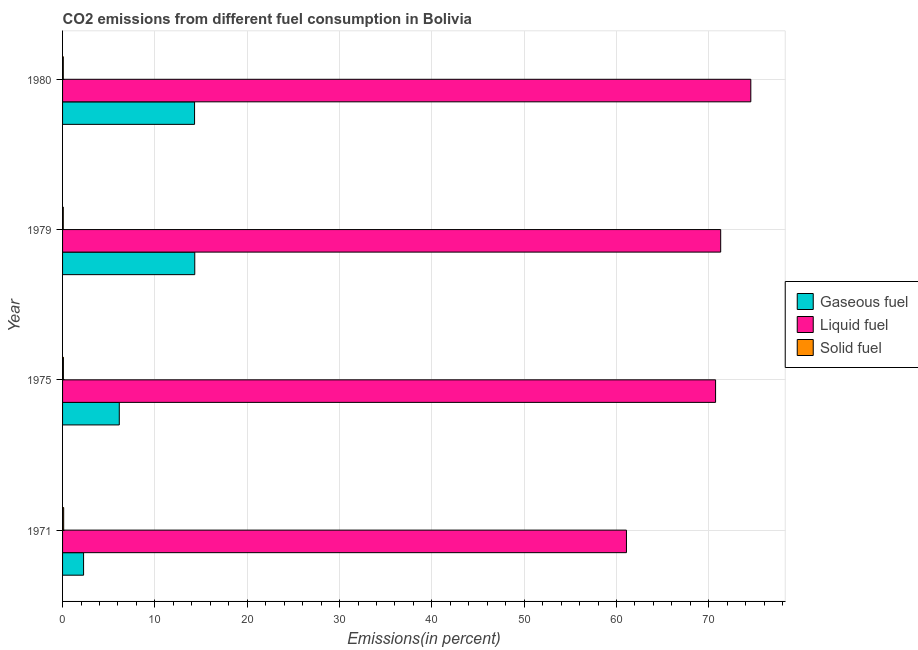How many different coloured bars are there?
Provide a succinct answer. 3. How many groups of bars are there?
Give a very brief answer. 4. In how many cases, is the number of bars for a given year not equal to the number of legend labels?
Offer a very short reply. 0. What is the percentage of gaseous fuel emission in 1971?
Your response must be concise. 2.28. Across all years, what is the maximum percentage of liquid fuel emission?
Keep it short and to the point. 74.55. Across all years, what is the minimum percentage of solid fuel emission?
Your answer should be very brief. 0.08. In which year was the percentage of gaseous fuel emission maximum?
Your response must be concise. 1979. In which year was the percentage of gaseous fuel emission minimum?
Your answer should be very brief. 1971. What is the total percentage of solid fuel emission in the graph?
Ensure brevity in your answer.  0.37. What is the difference between the percentage of solid fuel emission in 1971 and that in 1980?
Your response must be concise. 0.04. What is the difference between the percentage of liquid fuel emission in 1979 and the percentage of gaseous fuel emission in 1971?
Your answer should be very brief. 69.01. What is the average percentage of solid fuel emission per year?
Keep it short and to the point. 0.09. In the year 1975, what is the difference between the percentage of solid fuel emission and percentage of gaseous fuel emission?
Offer a terse response. -6.05. Is the difference between the percentage of solid fuel emission in 1975 and 1980 greater than the difference between the percentage of gaseous fuel emission in 1975 and 1980?
Ensure brevity in your answer.  Yes. What is the difference between the highest and the second highest percentage of gaseous fuel emission?
Your response must be concise. 0.02. What is the difference between the highest and the lowest percentage of liquid fuel emission?
Ensure brevity in your answer.  13.47. In how many years, is the percentage of solid fuel emission greater than the average percentage of solid fuel emission taken over all years?
Offer a very short reply. 1. Is the sum of the percentage of solid fuel emission in 1979 and 1980 greater than the maximum percentage of gaseous fuel emission across all years?
Give a very brief answer. No. What does the 2nd bar from the top in 1979 represents?
Keep it short and to the point. Liquid fuel. What does the 2nd bar from the bottom in 1980 represents?
Offer a terse response. Liquid fuel. Are all the bars in the graph horizontal?
Your response must be concise. Yes. How many years are there in the graph?
Offer a very short reply. 4. Are the values on the major ticks of X-axis written in scientific E-notation?
Offer a terse response. No. Does the graph contain any zero values?
Your response must be concise. No. Does the graph contain grids?
Keep it short and to the point. Yes. What is the title of the graph?
Provide a succinct answer. CO2 emissions from different fuel consumption in Bolivia. Does "Communicable diseases" appear as one of the legend labels in the graph?
Provide a succinct answer. No. What is the label or title of the X-axis?
Ensure brevity in your answer.  Emissions(in percent). What is the label or title of the Y-axis?
Your answer should be compact. Year. What is the Emissions(in percent) of Gaseous fuel in 1971?
Make the answer very short. 2.28. What is the Emissions(in percent) in Liquid fuel in 1971?
Offer a very short reply. 61.08. What is the Emissions(in percent) of Solid fuel in 1971?
Keep it short and to the point. 0.12. What is the Emissions(in percent) of Gaseous fuel in 1975?
Make the answer very short. 6.14. What is the Emissions(in percent) of Liquid fuel in 1975?
Keep it short and to the point. 70.73. What is the Emissions(in percent) of Solid fuel in 1975?
Your response must be concise. 0.09. What is the Emissions(in percent) of Gaseous fuel in 1979?
Provide a succinct answer. 14.32. What is the Emissions(in percent) of Liquid fuel in 1979?
Keep it short and to the point. 71.28. What is the Emissions(in percent) in Solid fuel in 1979?
Your response must be concise. 0.08. What is the Emissions(in percent) in Gaseous fuel in 1980?
Make the answer very short. 14.3. What is the Emissions(in percent) of Liquid fuel in 1980?
Provide a succinct answer. 74.55. What is the Emissions(in percent) in Solid fuel in 1980?
Provide a succinct answer. 0.08. Across all years, what is the maximum Emissions(in percent) of Gaseous fuel?
Offer a terse response. 14.32. Across all years, what is the maximum Emissions(in percent) of Liquid fuel?
Keep it short and to the point. 74.55. Across all years, what is the maximum Emissions(in percent) in Solid fuel?
Offer a terse response. 0.12. Across all years, what is the minimum Emissions(in percent) in Gaseous fuel?
Your answer should be compact. 2.28. Across all years, what is the minimum Emissions(in percent) of Liquid fuel?
Your response must be concise. 61.08. Across all years, what is the minimum Emissions(in percent) in Solid fuel?
Give a very brief answer. 0.08. What is the total Emissions(in percent) of Gaseous fuel in the graph?
Offer a terse response. 37.03. What is the total Emissions(in percent) of Liquid fuel in the graph?
Ensure brevity in your answer.  277.64. What is the total Emissions(in percent) of Solid fuel in the graph?
Your answer should be very brief. 0.37. What is the difference between the Emissions(in percent) of Gaseous fuel in 1971 and that in 1975?
Provide a short and direct response. -3.87. What is the difference between the Emissions(in percent) in Liquid fuel in 1971 and that in 1975?
Your answer should be compact. -9.65. What is the difference between the Emissions(in percent) in Solid fuel in 1971 and that in 1975?
Offer a very short reply. 0.03. What is the difference between the Emissions(in percent) of Gaseous fuel in 1971 and that in 1979?
Ensure brevity in your answer.  -12.04. What is the difference between the Emissions(in percent) in Liquid fuel in 1971 and that in 1979?
Offer a terse response. -10.21. What is the difference between the Emissions(in percent) of Solid fuel in 1971 and that in 1979?
Give a very brief answer. 0.04. What is the difference between the Emissions(in percent) of Gaseous fuel in 1971 and that in 1980?
Make the answer very short. -12.02. What is the difference between the Emissions(in percent) of Liquid fuel in 1971 and that in 1980?
Your answer should be very brief. -13.47. What is the difference between the Emissions(in percent) in Solid fuel in 1971 and that in 1980?
Your answer should be compact. 0.04. What is the difference between the Emissions(in percent) in Gaseous fuel in 1975 and that in 1979?
Provide a short and direct response. -8.18. What is the difference between the Emissions(in percent) in Liquid fuel in 1975 and that in 1979?
Offer a very short reply. -0.55. What is the difference between the Emissions(in percent) in Solid fuel in 1975 and that in 1979?
Make the answer very short. 0.01. What is the difference between the Emissions(in percent) in Gaseous fuel in 1975 and that in 1980?
Give a very brief answer. -8.15. What is the difference between the Emissions(in percent) of Liquid fuel in 1975 and that in 1980?
Offer a terse response. -3.82. What is the difference between the Emissions(in percent) of Solid fuel in 1975 and that in 1980?
Provide a short and direct response. 0.01. What is the difference between the Emissions(in percent) in Gaseous fuel in 1979 and that in 1980?
Ensure brevity in your answer.  0.02. What is the difference between the Emissions(in percent) in Liquid fuel in 1979 and that in 1980?
Keep it short and to the point. -3.26. What is the difference between the Emissions(in percent) of Solid fuel in 1979 and that in 1980?
Give a very brief answer. -0. What is the difference between the Emissions(in percent) of Gaseous fuel in 1971 and the Emissions(in percent) of Liquid fuel in 1975?
Make the answer very short. -68.46. What is the difference between the Emissions(in percent) of Gaseous fuel in 1971 and the Emissions(in percent) of Solid fuel in 1975?
Give a very brief answer. 2.19. What is the difference between the Emissions(in percent) of Liquid fuel in 1971 and the Emissions(in percent) of Solid fuel in 1975?
Provide a short and direct response. 60.99. What is the difference between the Emissions(in percent) in Gaseous fuel in 1971 and the Emissions(in percent) in Liquid fuel in 1979?
Your answer should be very brief. -69.01. What is the difference between the Emissions(in percent) of Gaseous fuel in 1971 and the Emissions(in percent) of Solid fuel in 1979?
Your response must be concise. 2.2. What is the difference between the Emissions(in percent) of Liquid fuel in 1971 and the Emissions(in percent) of Solid fuel in 1979?
Your response must be concise. 61. What is the difference between the Emissions(in percent) in Gaseous fuel in 1971 and the Emissions(in percent) in Liquid fuel in 1980?
Your answer should be compact. -72.27. What is the difference between the Emissions(in percent) of Gaseous fuel in 1971 and the Emissions(in percent) of Solid fuel in 1980?
Provide a succinct answer. 2.2. What is the difference between the Emissions(in percent) of Liquid fuel in 1971 and the Emissions(in percent) of Solid fuel in 1980?
Offer a terse response. 61. What is the difference between the Emissions(in percent) of Gaseous fuel in 1975 and the Emissions(in percent) of Liquid fuel in 1979?
Your answer should be very brief. -65.14. What is the difference between the Emissions(in percent) in Gaseous fuel in 1975 and the Emissions(in percent) in Solid fuel in 1979?
Your answer should be very brief. 6.07. What is the difference between the Emissions(in percent) in Liquid fuel in 1975 and the Emissions(in percent) in Solid fuel in 1979?
Keep it short and to the point. 70.65. What is the difference between the Emissions(in percent) in Gaseous fuel in 1975 and the Emissions(in percent) in Liquid fuel in 1980?
Make the answer very short. -68.41. What is the difference between the Emissions(in percent) of Gaseous fuel in 1975 and the Emissions(in percent) of Solid fuel in 1980?
Make the answer very short. 6.06. What is the difference between the Emissions(in percent) of Liquid fuel in 1975 and the Emissions(in percent) of Solid fuel in 1980?
Your answer should be compact. 70.65. What is the difference between the Emissions(in percent) in Gaseous fuel in 1979 and the Emissions(in percent) in Liquid fuel in 1980?
Make the answer very short. -60.23. What is the difference between the Emissions(in percent) of Gaseous fuel in 1979 and the Emissions(in percent) of Solid fuel in 1980?
Provide a succinct answer. 14.24. What is the difference between the Emissions(in percent) in Liquid fuel in 1979 and the Emissions(in percent) in Solid fuel in 1980?
Ensure brevity in your answer.  71.21. What is the average Emissions(in percent) of Gaseous fuel per year?
Make the answer very short. 9.26. What is the average Emissions(in percent) in Liquid fuel per year?
Offer a very short reply. 69.41. What is the average Emissions(in percent) of Solid fuel per year?
Provide a short and direct response. 0.09. In the year 1971, what is the difference between the Emissions(in percent) in Gaseous fuel and Emissions(in percent) in Liquid fuel?
Ensure brevity in your answer.  -58.8. In the year 1971, what is the difference between the Emissions(in percent) in Gaseous fuel and Emissions(in percent) in Solid fuel?
Your answer should be very brief. 2.16. In the year 1971, what is the difference between the Emissions(in percent) of Liquid fuel and Emissions(in percent) of Solid fuel?
Offer a very short reply. 60.96. In the year 1975, what is the difference between the Emissions(in percent) of Gaseous fuel and Emissions(in percent) of Liquid fuel?
Give a very brief answer. -64.59. In the year 1975, what is the difference between the Emissions(in percent) of Gaseous fuel and Emissions(in percent) of Solid fuel?
Offer a very short reply. 6.05. In the year 1975, what is the difference between the Emissions(in percent) of Liquid fuel and Emissions(in percent) of Solid fuel?
Provide a succinct answer. 70.64. In the year 1979, what is the difference between the Emissions(in percent) in Gaseous fuel and Emissions(in percent) in Liquid fuel?
Provide a succinct answer. -56.97. In the year 1979, what is the difference between the Emissions(in percent) in Gaseous fuel and Emissions(in percent) in Solid fuel?
Your answer should be compact. 14.24. In the year 1979, what is the difference between the Emissions(in percent) in Liquid fuel and Emissions(in percent) in Solid fuel?
Offer a terse response. 71.21. In the year 1980, what is the difference between the Emissions(in percent) in Gaseous fuel and Emissions(in percent) in Liquid fuel?
Your response must be concise. -60.25. In the year 1980, what is the difference between the Emissions(in percent) in Gaseous fuel and Emissions(in percent) in Solid fuel?
Keep it short and to the point. 14.22. In the year 1980, what is the difference between the Emissions(in percent) of Liquid fuel and Emissions(in percent) of Solid fuel?
Provide a succinct answer. 74.47. What is the ratio of the Emissions(in percent) of Gaseous fuel in 1971 to that in 1975?
Provide a succinct answer. 0.37. What is the ratio of the Emissions(in percent) of Liquid fuel in 1971 to that in 1975?
Your answer should be very brief. 0.86. What is the ratio of the Emissions(in percent) in Solid fuel in 1971 to that in 1975?
Provide a succinct answer. 1.33. What is the ratio of the Emissions(in percent) of Gaseous fuel in 1971 to that in 1979?
Offer a terse response. 0.16. What is the ratio of the Emissions(in percent) of Liquid fuel in 1971 to that in 1979?
Ensure brevity in your answer.  0.86. What is the ratio of the Emissions(in percent) of Solid fuel in 1971 to that in 1979?
Your response must be concise. 1.55. What is the ratio of the Emissions(in percent) in Gaseous fuel in 1971 to that in 1980?
Offer a very short reply. 0.16. What is the ratio of the Emissions(in percent) in Liquid fuel in 1971 to that in 1980?
Your response must be concise. 0.82. What is the ratio of the Emissions(in percent) of Solid fuel in 1971 to that in 1980?
Your response must be concise. 1.52. What is the ratio of the Emissions(in percent) in Gaseous fuel in 1975 to that in 1979?
Offer a terse response. 0.43. What is the ratio of the Emissions(in percent) in Liquid fuel in 1975 to that in 1979?
Make the answer very short. 0.99. What is the ratio of the Emissions(in percent) in Solid fuel in 1975 to that in 1979?
Offer a terse response. 1.17. What is the ratio of the Emissions(in percent) in Gaseous fuel in 1975 to that in 1980?
Offer a very short reply. 0.43. What is the ratio of the Emissions(in percent) of Liquid fuel in 1975 to that in 1980?
Provide a short and direct response. 0.95. What is the ratio of the Emissions(in percent) in Solid fuel in 1975 to that in 1980?
Your answer should be compact. 1.15. What is the ratio of the Emissions(in percent) in Liquid fuel in 1979 to that in 1980?
Give a very brief answer. 0.96. What is the difference between the highest and the second highest Emissions(in percent) of Gaseous fuel?
Make the answer very short. 0.02. What is the difference between the highest and the second highest Emissions(in percent) of Liquid fuel?
Your answer should be compact. 3.26. What is the difference between the highest and the second highest Emissions(in percent) of Solid fuel?
Offer a terse response. 0.03. What is the difference between the highest and the lowest Emissions(in percent) in Gaseous fuel?
Provide a succinct answer. 12.04. What is the difference between the highest and the lowest Emissions(in percent) in Liquid fuel?
Provide a short and direct response. 13.47. What is the difference between the highest and the lowest Emissions(in percent) of Solid fuel?
Your answer should be very brief. 0.04. 